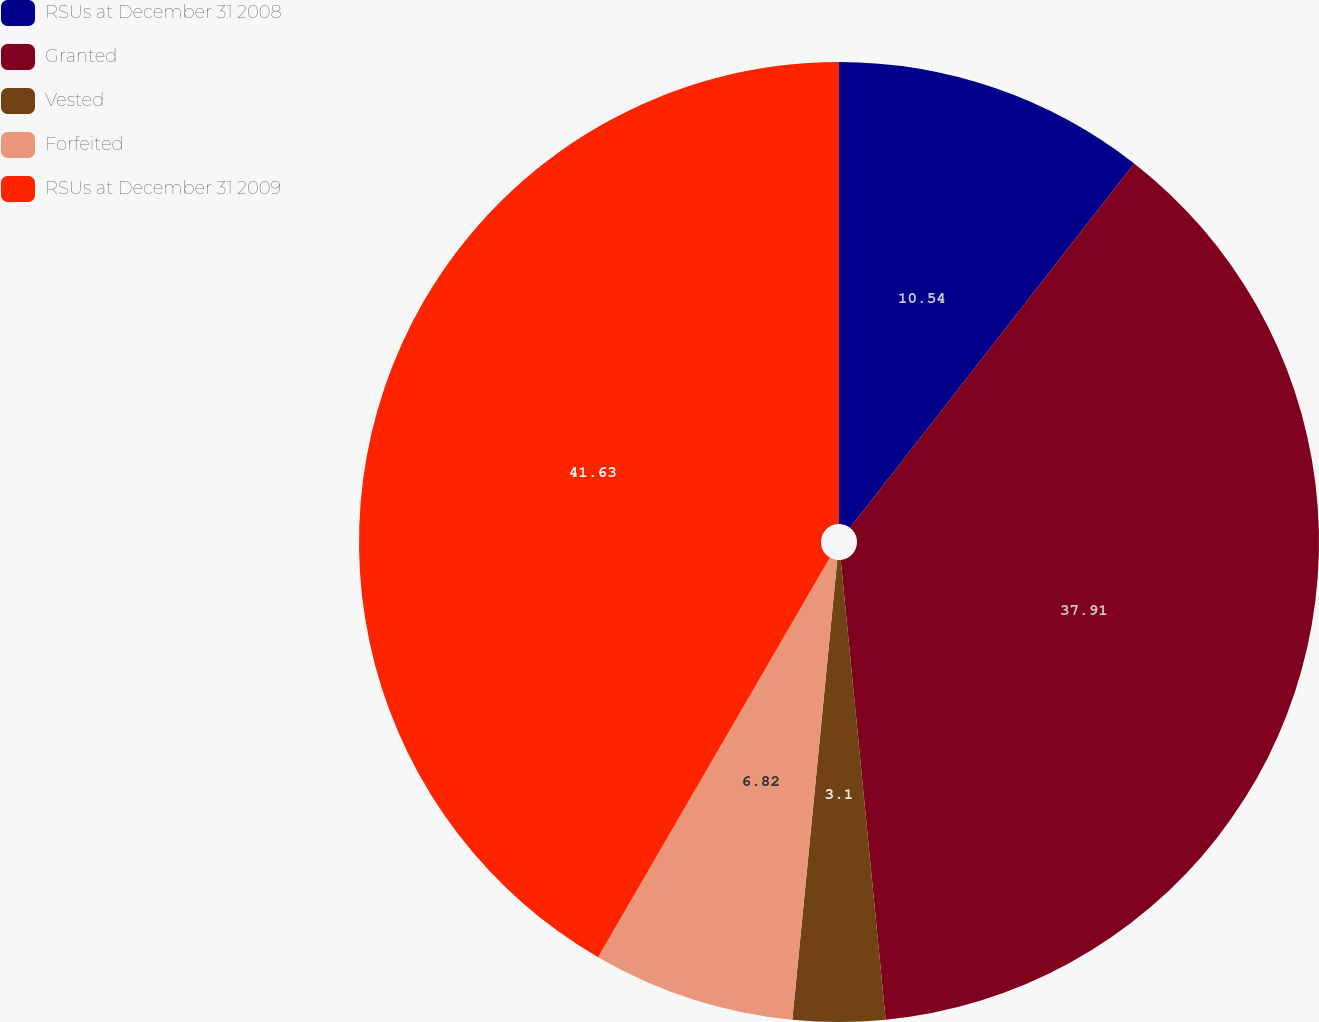<chart> <loc_0><loc_0><loc_500><loc_500><pie_chart><fcel>RSUs at December 31 2008<fcel>Granted<fcel>Vested<fcel>Forfeited<fcel>RSUs at December 31 2009<nl><fcel>10.54%<fcel>37.91%<fcel>3.1%<fcel>6.82%<fcel>41.63%<nl></chart> 